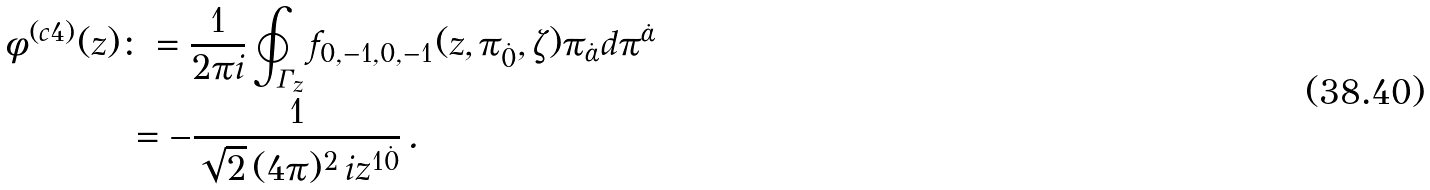<formula> <loc_0><loc_0><loc_500><loc_500>\phi ^ { ( c 4 ) } ( z ) & \colon = \frac { 1 } { 2 \pi i } \oint _ { \varGamma _ { z } } f _ { 0 , - 1 , 0 , - 1 } ( z , \pi _ { \dot { 0 } } , \zeta ) \pi _ { \dot { \alpha } } d \pi ^ { \dot { \alpha } } \\ & \, = - \frac { 1 } { \sqrt { 2 } \, ( 4 \pi ) ^ { 2 } \, i z ^ { 1 \dot { 0 } } } \, .</formula> 